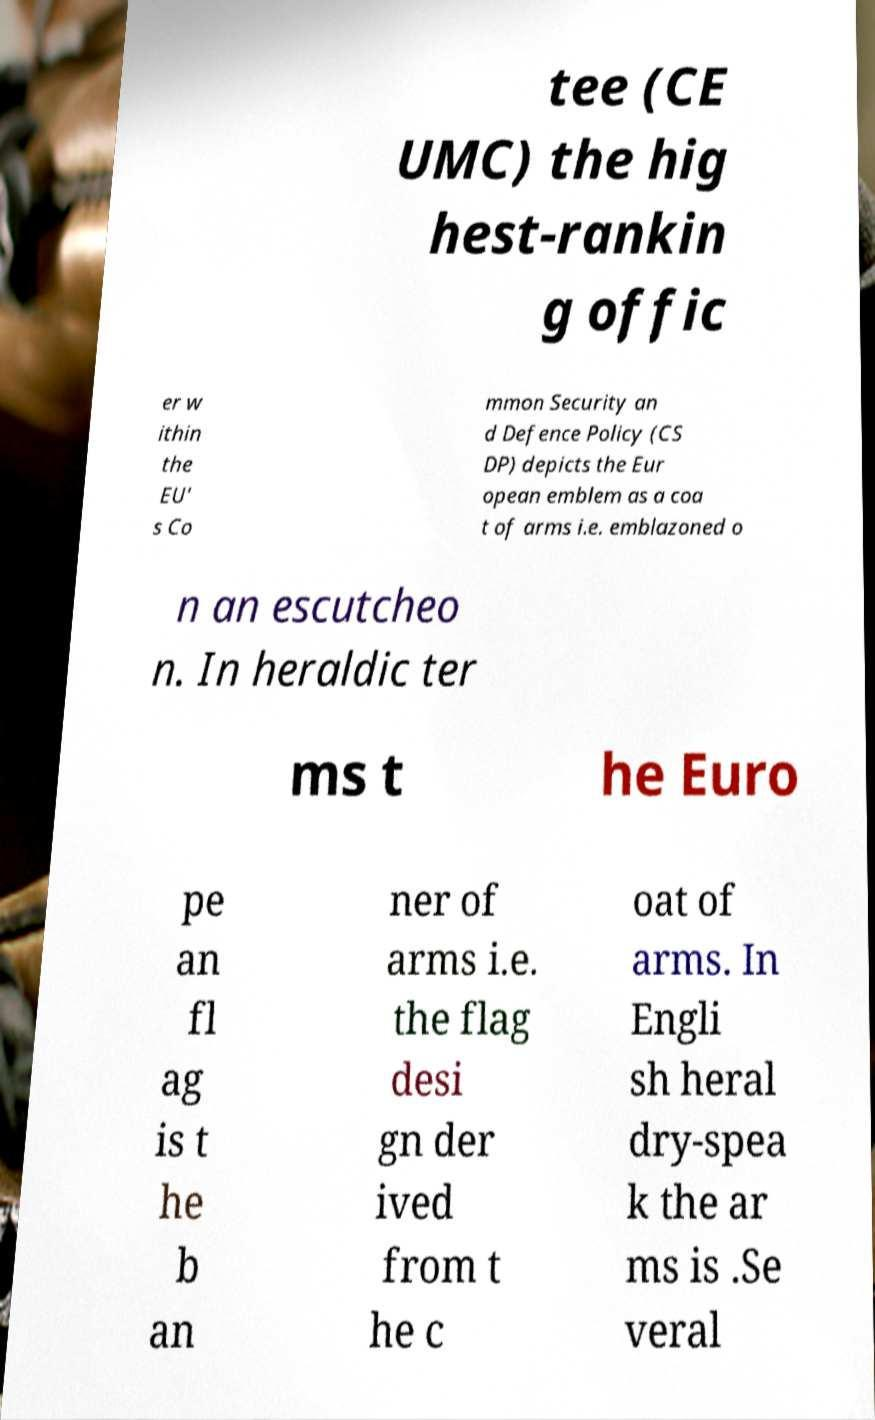Can you read and provide the text displayed in the image?This photo seems to have some interesting text. Can you extract and type it out for me? tee (CE UMC) the hig hest-rankin g offic er w ithin the EU' s Co mmon Security an d Defence Policy (CS DP) depicts the Eur opean emblem as a coa t of arms i.e. emblazoned o n an escutcheo n. In heraldic ter ms t he Euro pe an fl ag is t he b an ner of arms i.e. the flag desi gn der ived from t he c oat of arms. In Engli sh heral dry-spea k the ar ms is .Se veral 